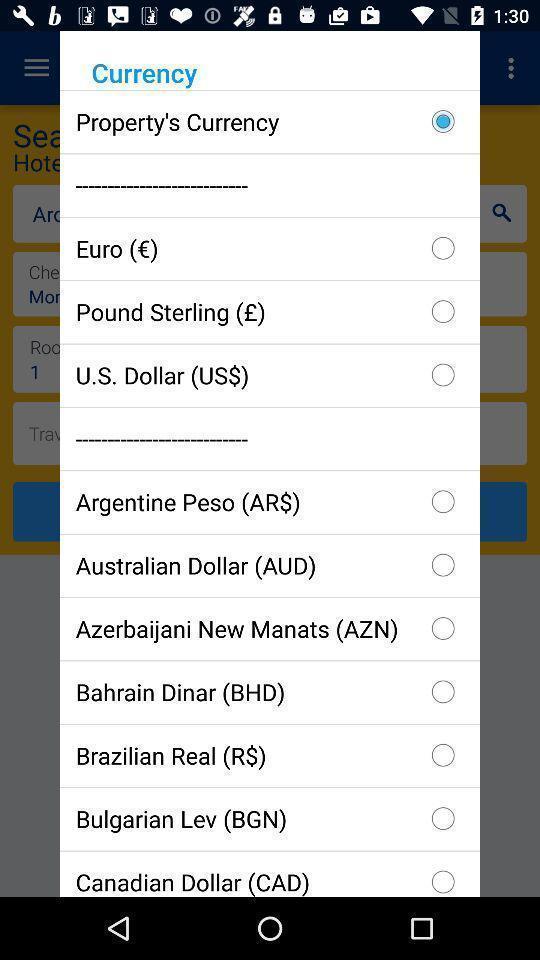Tell me what you see in this picture. Pop-up with currency related options in an accommodation finder app. 